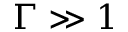Convert formula to latex. <formula><loc_0><loc_0><loc_500><loc_500>\Gamma \gg 1</formula> 